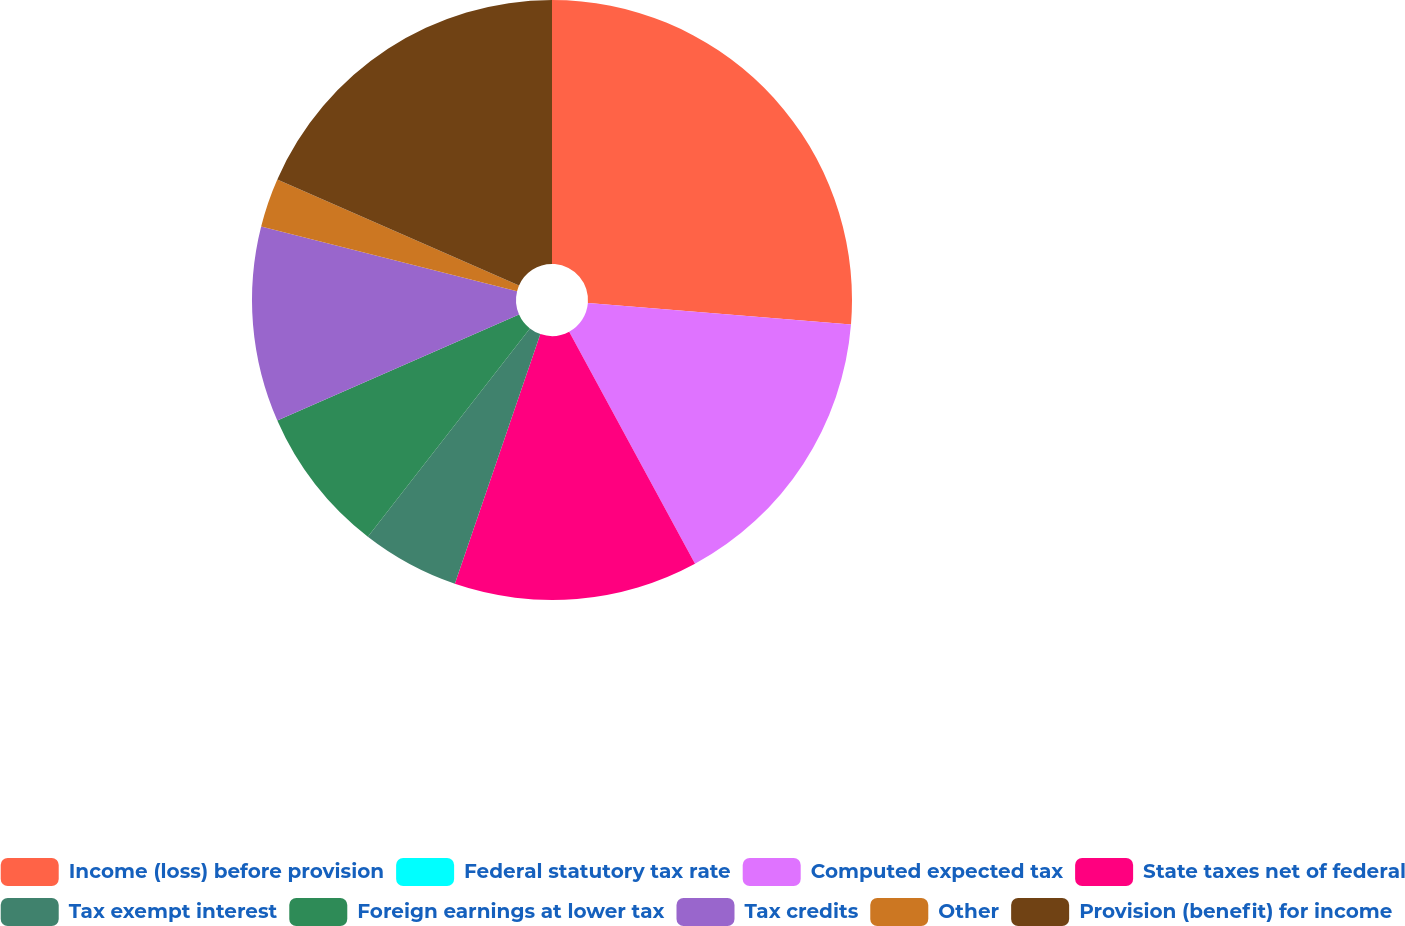Convert chart. <chart><loc_0><loc_0><loc_500><loc_500><pie_chart><fcel>Income (loss) before provision<fcel>Federal statutory tax rate<fcel>Computed expected tax<fcel>State taxes net of federal<fcel>Tax exempt interest<fcel>Foreign earnings at lower tax<fcel>Tax credits<fcel>Other<fcel>Provision (benefit) for income<nl><fcel>26.31%<fcel>0.0%<fcel>15.79%<fcel>13.16%<fcel>5.27%<fcel>7.9%<fcel>10.53%<fcel>2.64%<fcel>18.42%<nl></chart> 